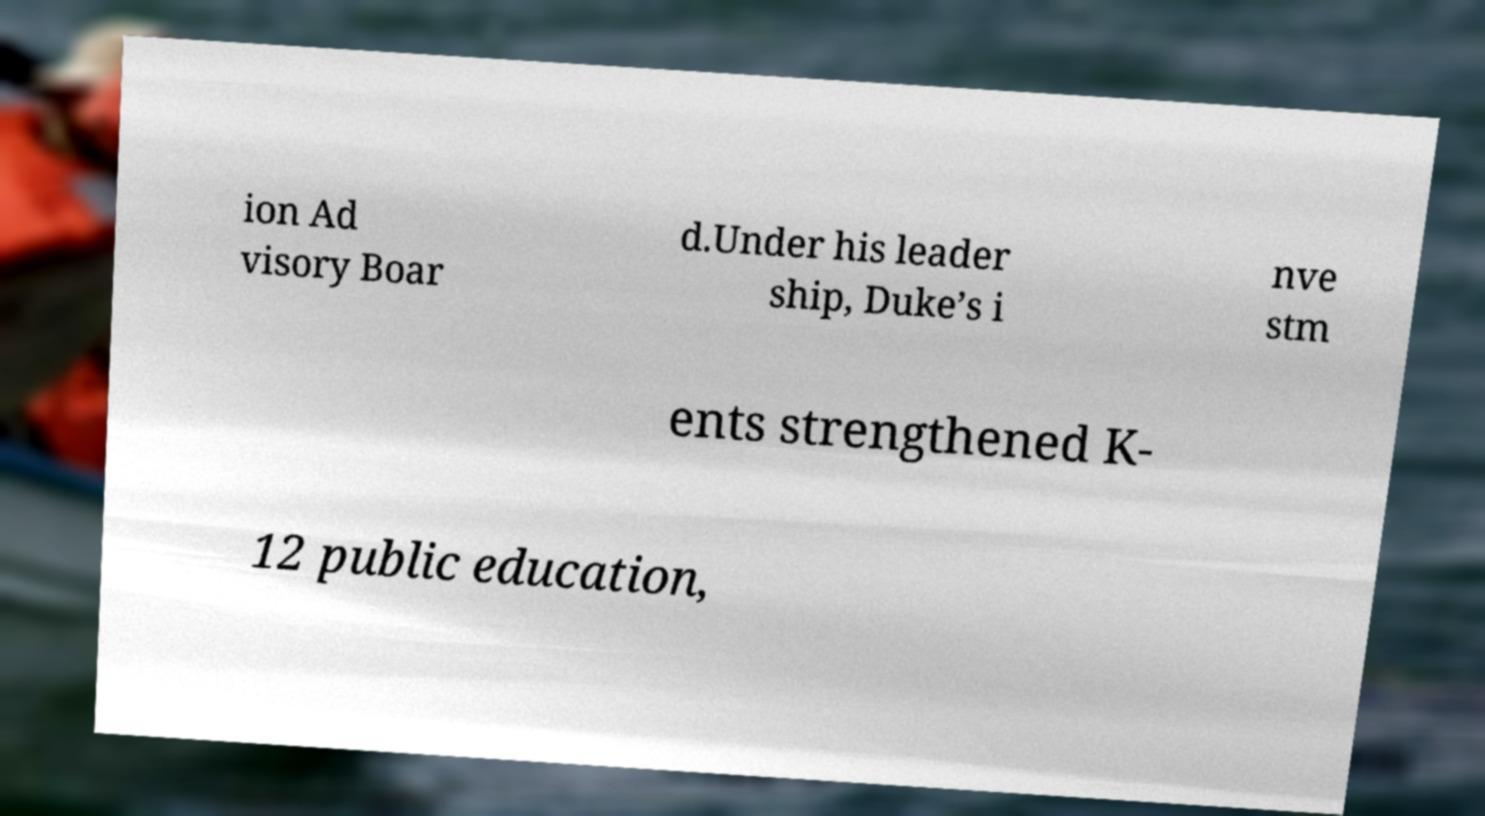For documentation purposes, I need the text within this image transcribed. Could you provide that? ion Ad visory Boar d.Under his leader ship, Duke’s i nve stm ents strengthened K- 12 public education, 